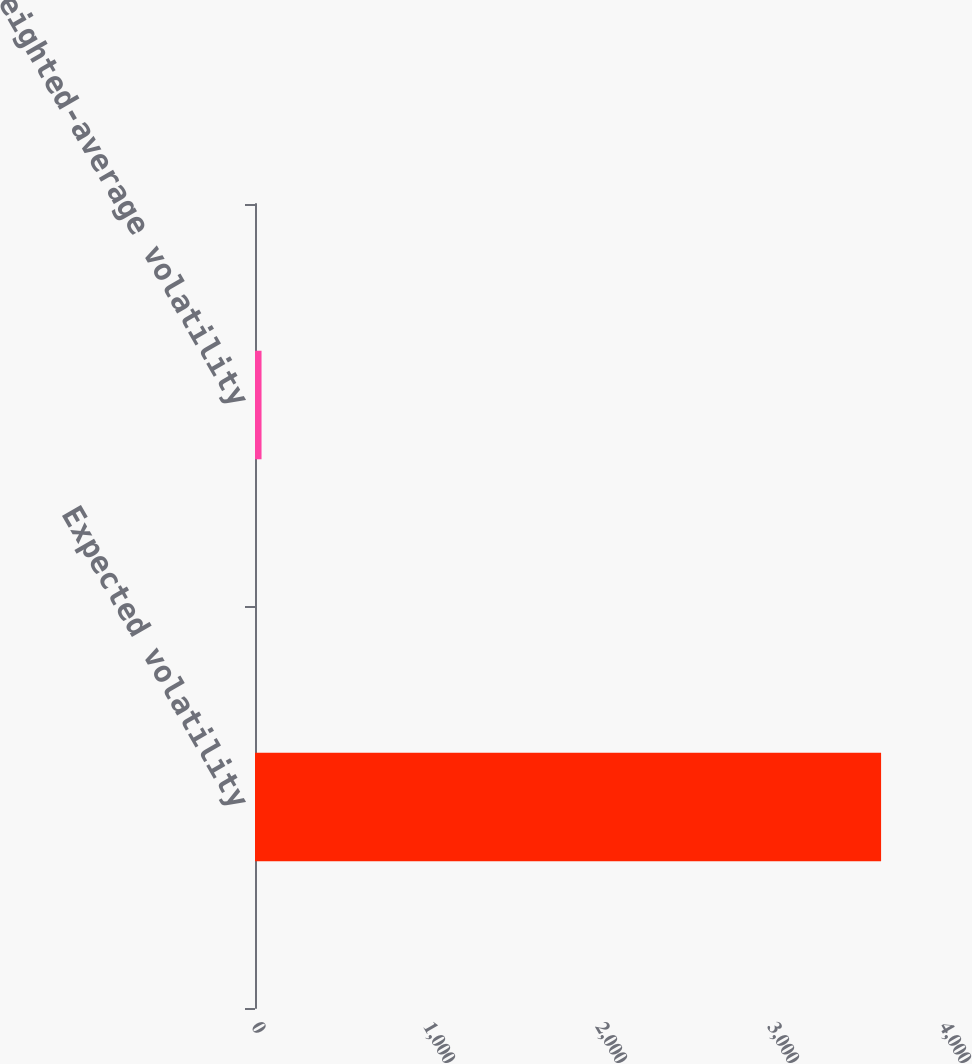Convert chart. <chart><loc_0><loc_0><loc_500><loc_500><bar_chart><fcel>Expected volatility<fcel>Weighted-average volatility<nl><fcel>3640<fcel>38<nl></chart> 